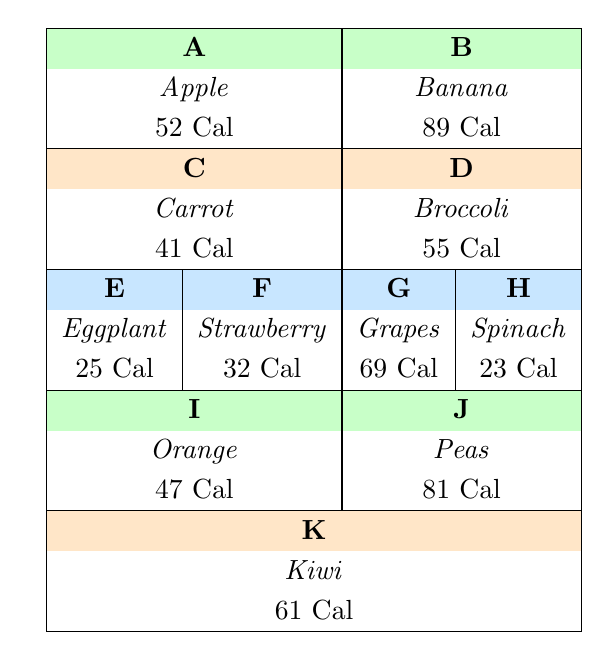What is the calorie content of a Banana? Looking at the table, the calorie content for Banana is presented in the row for symbol B. It clearly states that Banana contains 89 calories.
Answer: 89 Which fruit has the highest Vitamin C content? By examining the Vitamin C values in the table, we can see that Kiwi has 92.7 mg of Vitamin C, which is the highest among all the listed fruits and vegetables.
Answer: Kiwi How many calories are present in total for the fruits listed? We need to sum up the calories for each fruit: Apple (52) + Banana (89) + Strawberry (32) + Grapes (69) + Orange (47) + Kiwi (61) = 410 calories total.
Answer: 410 True or False: Spinach has more calories than Broccoli. Referring to the table, Spinach has 23 calories, while Broccoli has 55 calories. Hence, the statement is false.
Answer: False What is the average calorie content of the vegetables listed? The vegetables in the table are Carrot, Broccoli, Eggplant, Spinach, and Peas. Their calorie contents are: Carrot (41), Broccoli (55), Eggplant (25), Spinach (23), and Peas (81). The total is 41 + 55 + 25 + 23 + 81 = 225 calories. There are 5 vegetables, so the average is 225 / 5 = 45.
Answer: 45 Which fruit has the least sugar content? We need to compare the sugar content across all fruits. Checking the values, Eggplant (3.2) has lower sugar compared to Apple (10), Banana (12), Strawberry (4.9), Grapes (16), and Orange (9.4). Therefore, Eggplant has the least sugar content.
Answer: Eggplant What is the total fiber content of Grapes and Kiwi combined? The fiber content for Grapes is 0.9 and for Kiwi is 3. Adding these together gives us 0.9 + 3 = 3.9.
Answer: 3.9 Is the fiber content of a Carrot greater than that of a Banana? The fiber content for Carrot is 2.8 and for Banana is 2.6. Since 2.8 is greater than 2.6, the statement is true.
Answer: True 